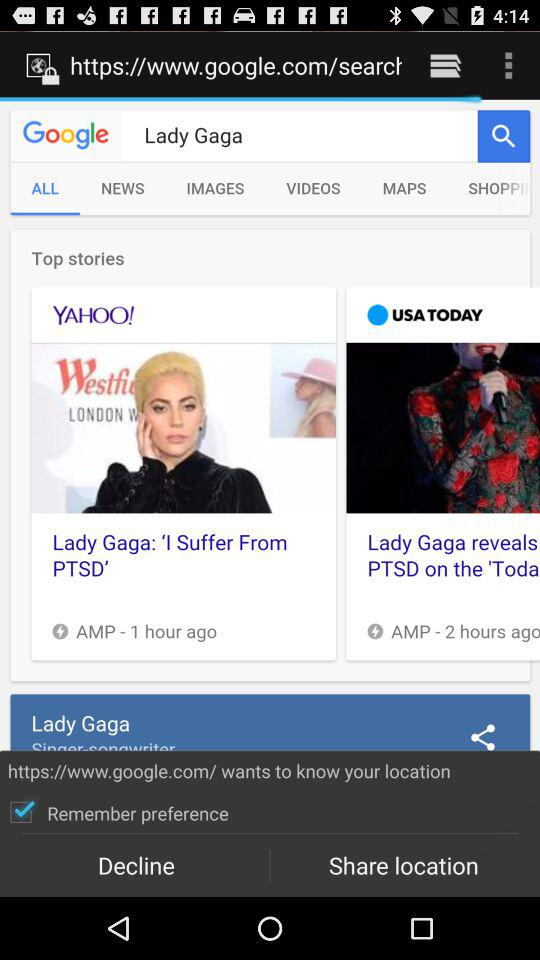How many top stories are there?
Answer the question using a single word or phrase. 2 